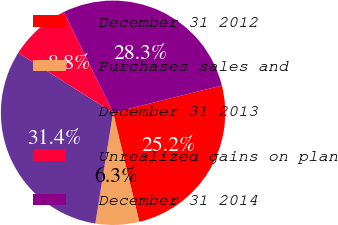Convert chart to OTSL. <chart><loc_0><loc_0><loc_500><loc_500><pie_chart><fcel>December 31 2012<fcel>Purchases sales and<fcel>December 31 2013<fcel>Unrealized gains on plan<fcel>December 31 2014<nl><fcel>25.16%<fcel>6.29%<fcel>31.45%<fcel>8.81%<fcel>28.3%<nl></chart> 